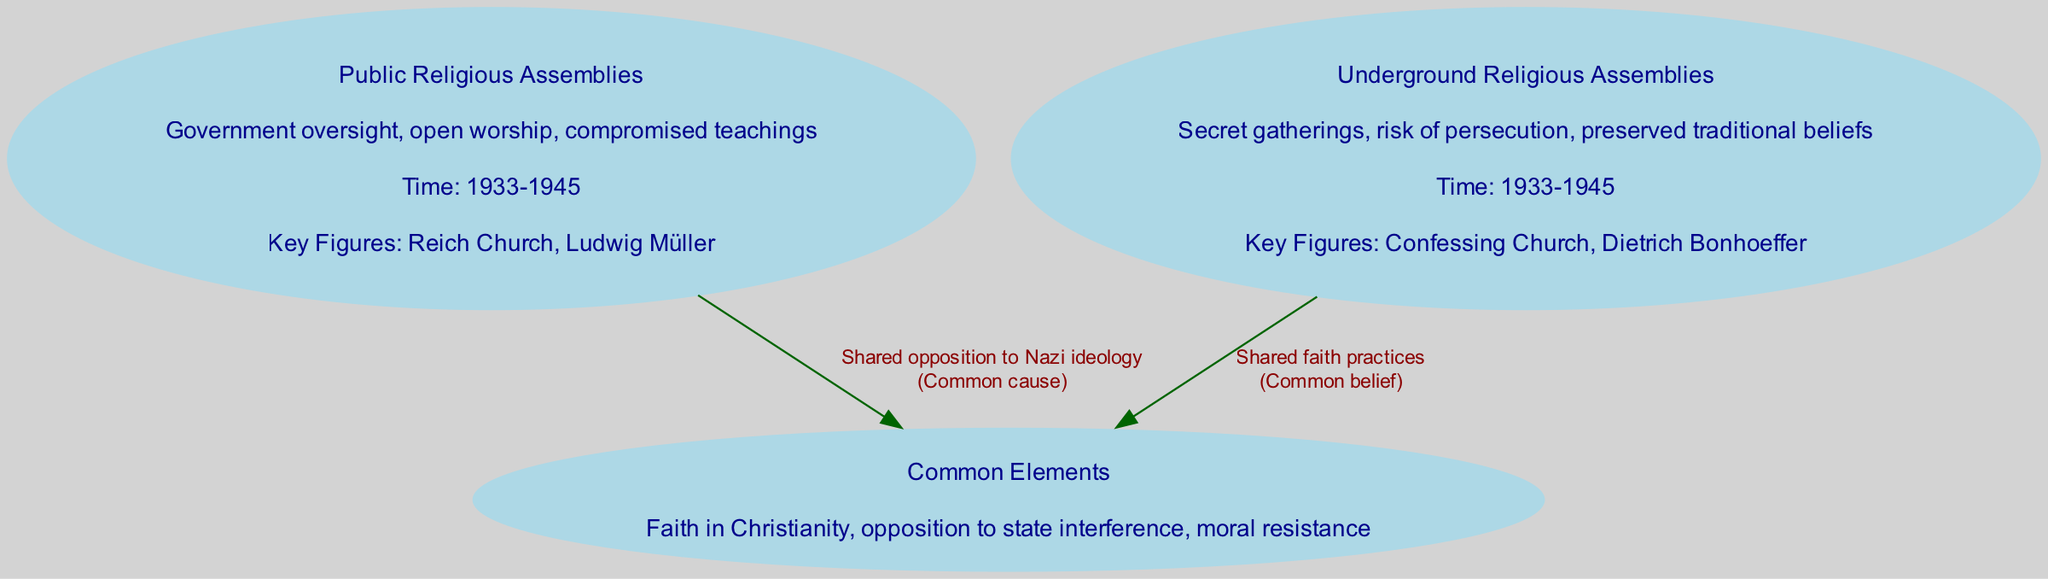What are the key figures associated with public religious assemblies? The diagram indicates that the key figures associated with public religious assemblies are the Reich Church and Ludwig Müller, which are listed under the details of the corresponding node.
Answer: Reich Church, Ludwig Müller How many nodes are present in the diagram? The diagram contains three nodes: Public Religious Assemblies, Underground Religious Assemblies, and Common Elements, which can be counted directly.
Answer: 3 What is the description of underground religious assemblies? According to the node details in the diagram, the description of underground religious assemblies includes "Secret gatherings, risk of persecution, preserved traditional beliefs," which is presented within the node.
Answer: Secret gatherings, risk of persecution, preserved traditional beliefs What is a common element shared between both types of assemblies? The diagram identifies a common element shared between both public and underground religious assemblies as "Faith in Christianity," which is noted under the Common Elements node.
Answer: Faith in Christianity What relationship is specified for the edge from public religious assemblies to common elements? The edge from public religious assemblies to common elements is labeled as "Shared opposition to Nazi ideology," indicating the nature of the connection between these nodes.
Answer: Shared opposition to Nazi ideology Which type of assemblies experienced government oversight? The diagram states that public religious assemblies experienced government oversight, as mentioned in the details of that node.
Answer: Public religious assemblies What risk was involved with underground religious assemblies? The diagram describes that underground religious assemblies faced the risk of persecution, as detailed in the corresponding node.
Answer: Risk of persecution In what time period did these religious assemblies occur? Both public and underground religious assemblies are noted to have occurred during the time period of 1933-1945, as indicated in their respective nodes.
Answer: 1933-1945 